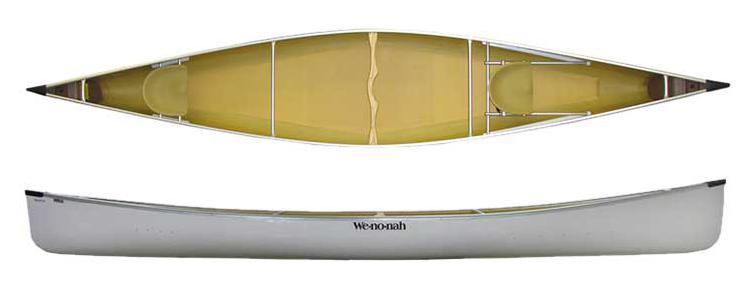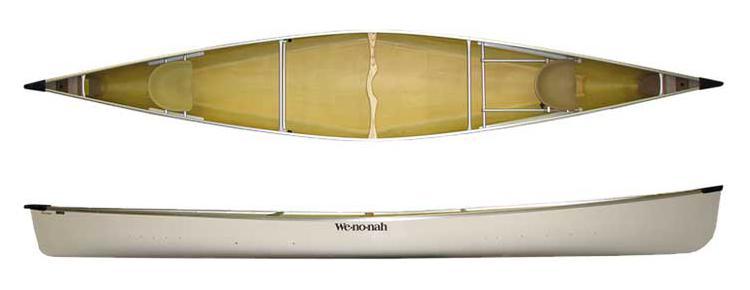The first image is the image on the left, the second image is the image on the right. Assess this claim about the two images: "There is one canoe in each image, and they are all the same color inside as out.". Correct or not? Answer yes or no. No. The first image is the image on the left, the second image is the image on the right. Examine the images to the left and right. Is the description "Both images show two views of a yellow-bodied canoe, and one features at least one woven black seat inside the canoe." accurate? Answer yes or no. No. 